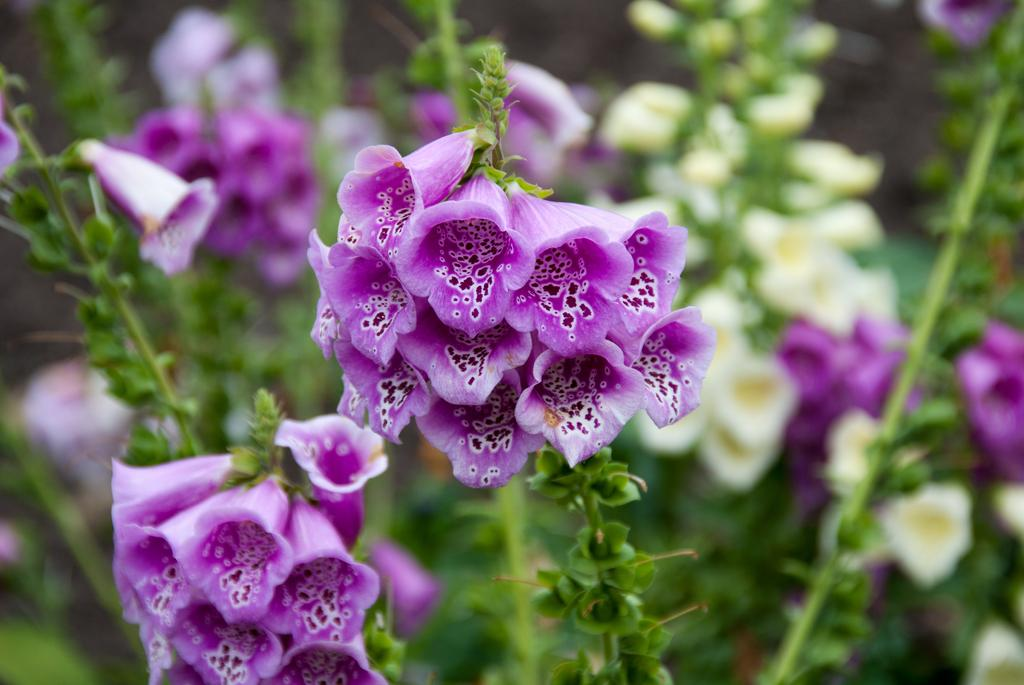What colors are the flowers in the image? There are purple and white flowers in the image. What else can be seen in the image besides flowers? There are leaves in the image. How would you describe the background in the image? The backdrop is blurred. What type of stamp is on the dinner plate in the image? There is no dinner plate or stamp present in the image; it features flowers and leaves with a blurred backdrop. 